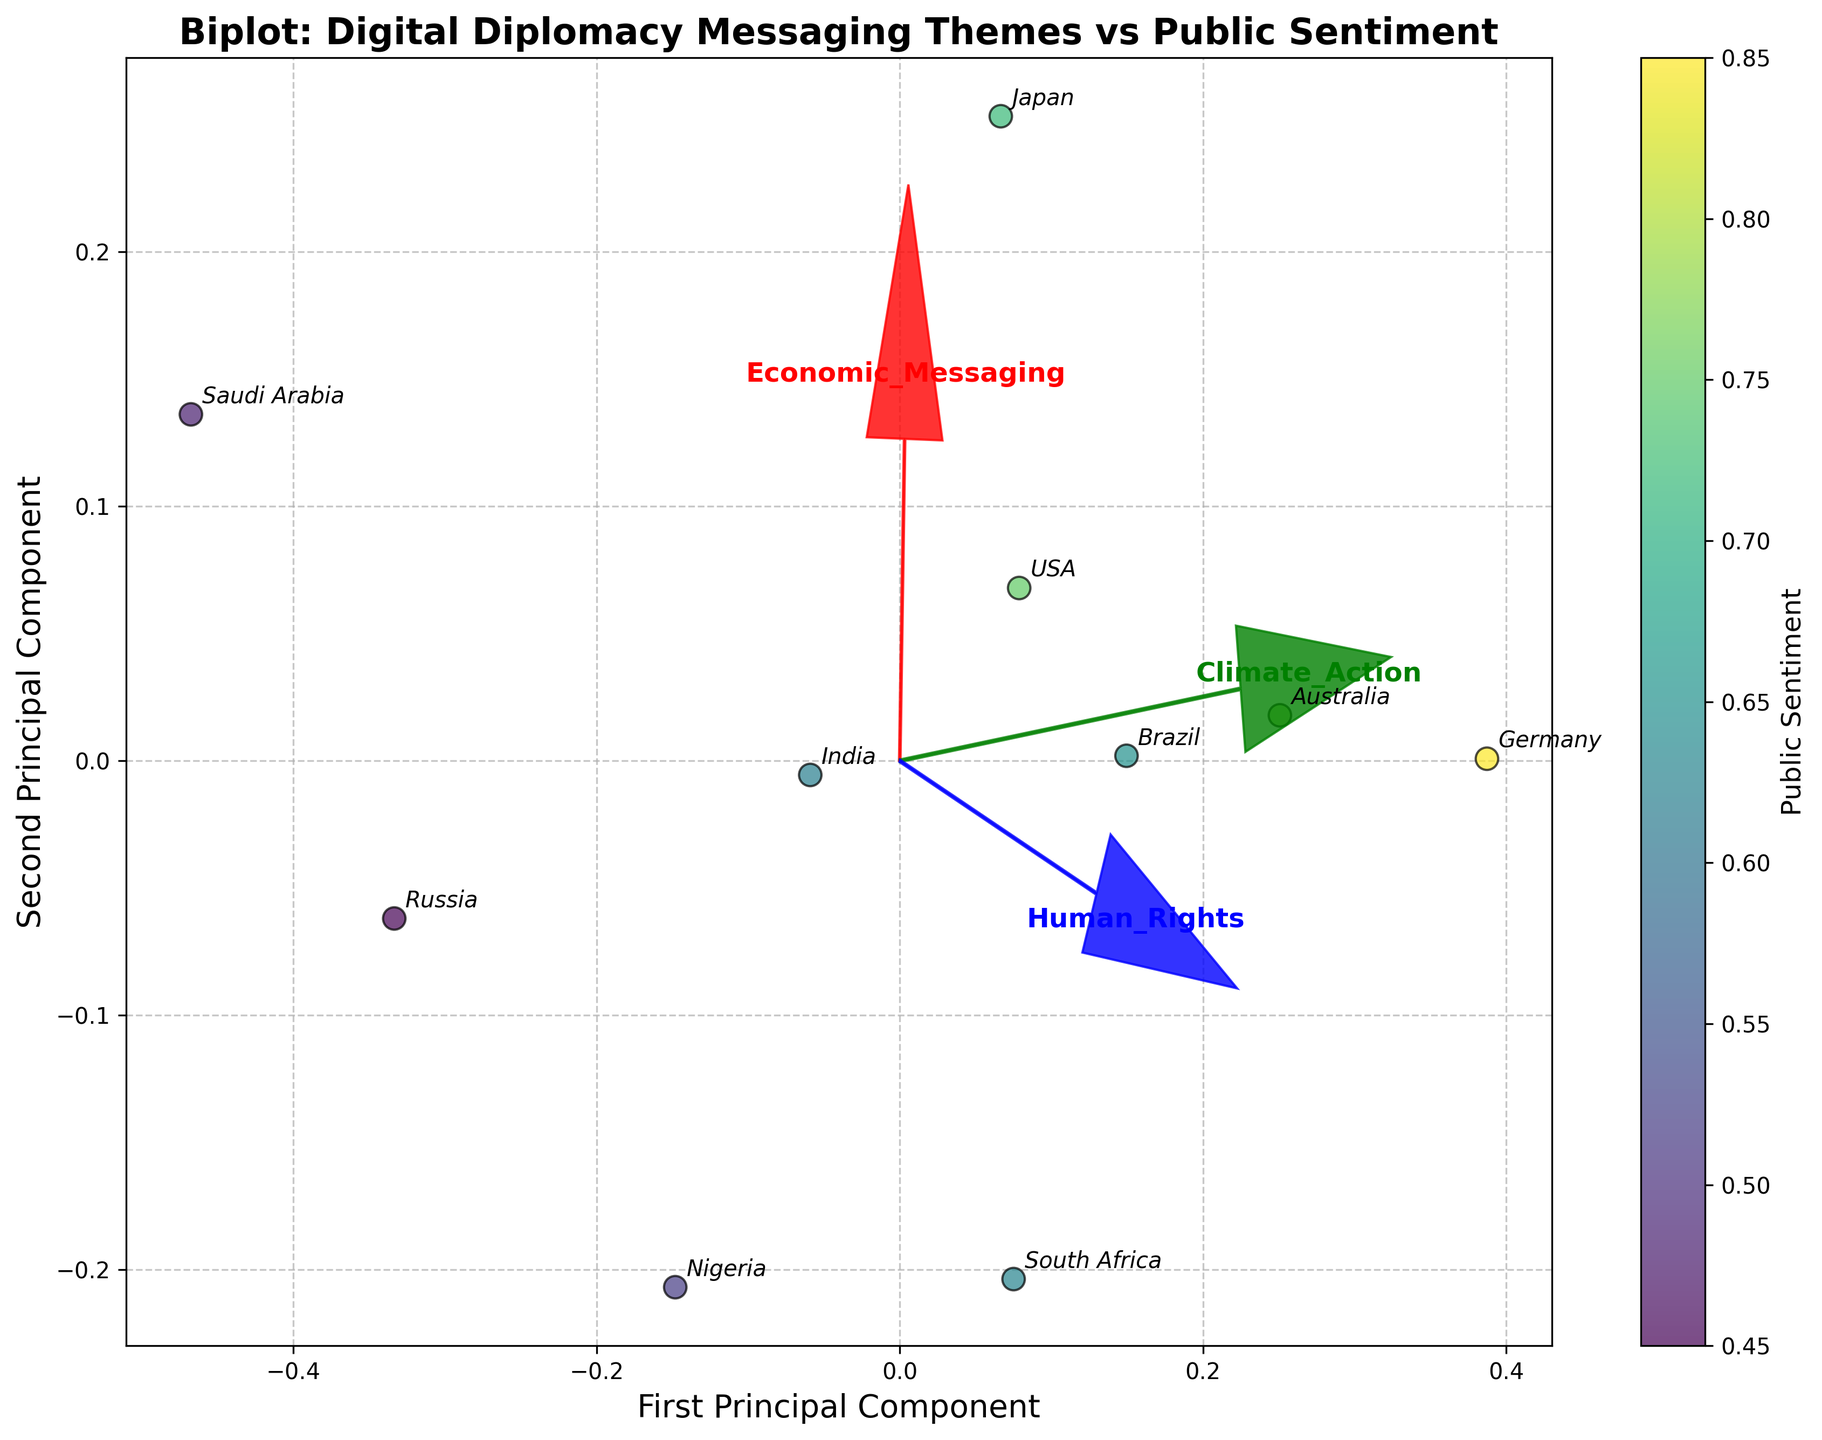What does the title of the plot indicate? The title indicates that the plot is a biplot showing the relationship between different themes in digital diplomacy messaging and public sentiment across various cultural regions.
Answer: It indicates the relationship between messaging themes and sentiment How many principal components are shown in the biplot? The x-axis is labeled as the "First Principal Component" and the y-axis as the "Second Principal Component," which suggests that two principal components are shown in the biplot.
Answer: Two Which cultural region has the highest public sentiment score? By examining the color gradient and the labels, Germany in Western Europe has the highest public sentiment score, as it appears in the darkest color on the color bar.
Answer: Western Europe (Germany) What are the directions and colors of the arrows representing different messaging themes? The arrows representing 'Economic_Messaging,' 'Climate_Action,' and 'Human_Rights' point in different directions and are colored red, green, and blue, respectively.
Answer: Red: Economic_Messaging, Green: Climate_Action, Blue: Human_Rights How is public sentiment represented in the biplot? Public sentiment is represented by the colors of the data points, with a color gradient shown in the color bar ranging from yellow to dark purple.
Answer: Color gradient of data points Which two countries are located closest to each other on the biplot? By observing the proximity of data points, the USA and Australia are located closest to each other on the biplot.
Answer: USA and Australia What does the length of the arrows represent in the biplot? The length of the arrows represents the contribution of each original feature (messaging theme) to the variance captured by the principal components, with longer arrows indicating a stronger contribution.
Answer: Contribution of features to variance Which country has the most significant contribution from economic messaging based on the biplot? The USA shows a higher position along the first principal component, which aligns more with the direction of the 'Economic_Messaging' arrow, indicating a significant contribution from economic messaging.
Answer: USA What might be inferred if a country's data point is not aligned with any of the arrows? If a country's data point is not aligned with any of the arrows, it suggests that its messaging themes do not strongly align with those particular themes or may be a mix of various themes.
Answer: Mixed or unaligned messaging themes How does the public sentiment of countries in the Middle East compare to those in Western Europe? The public sentiment of countries in the Middle East, represented by the position and color of Saudi Arabia, appears to be lower than that of Germany in Western Europe, which has darker public sentiment coloring.
Answer: Lower in the Middle East 